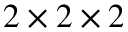Convert formula to latex. <formula><loc_0><loc_0><loc_500><loc_500>2 \times 2 \times 2</formula> 